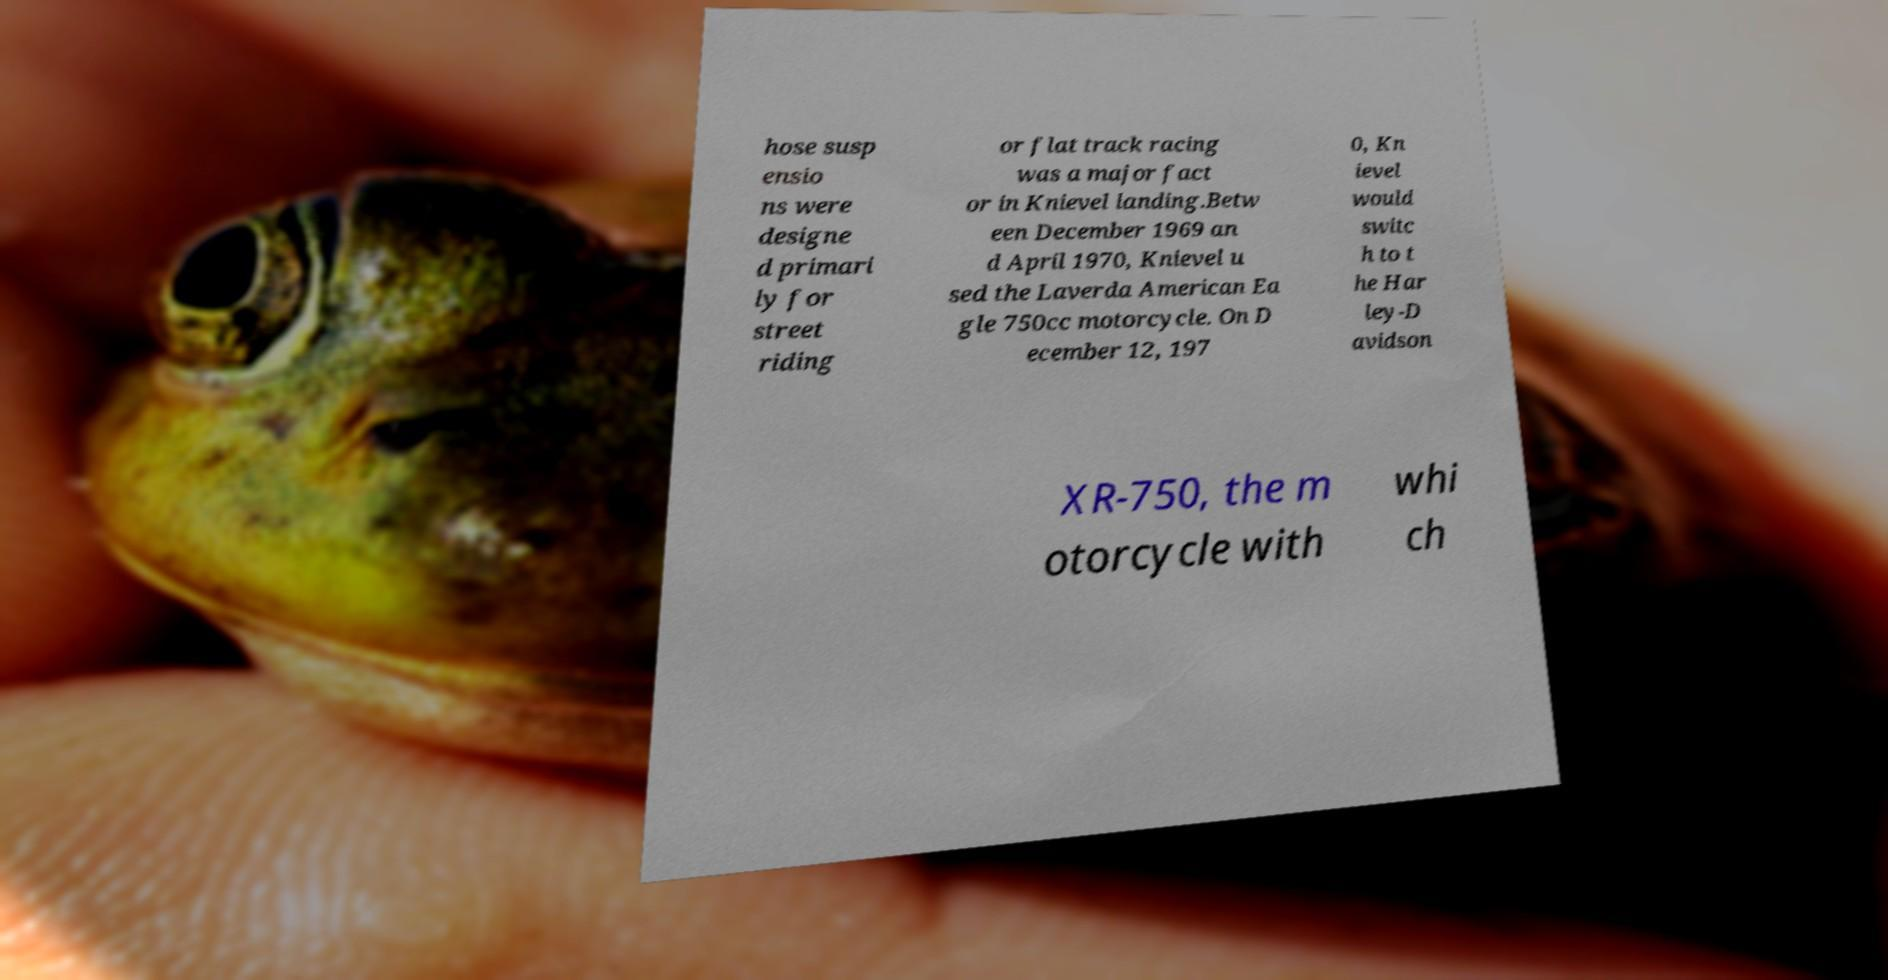Can you read and provide the text displayed in the image?This photo seems to have some interesting text. Can you extract and type it out for me? hose susp ensio ns were designe d primari ly for street riding or flat track racing was a major fact or in Knievel landing.Betw een December 1969 an d April 1970, Knievel u sed the Laverda American Ea gle 750cc motorcycle. On D ecember 12, 197 0, Kn ievel would switc h to t he Har ley-D avidson XR-750, the m otorcycle with whi ch 